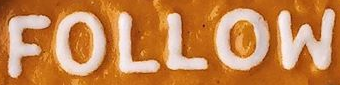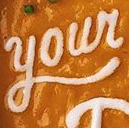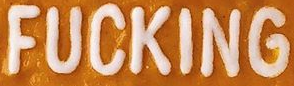What text is displayed in these images sequentially, separated by a semicolon? FOLLOW; Your; FUCKING 